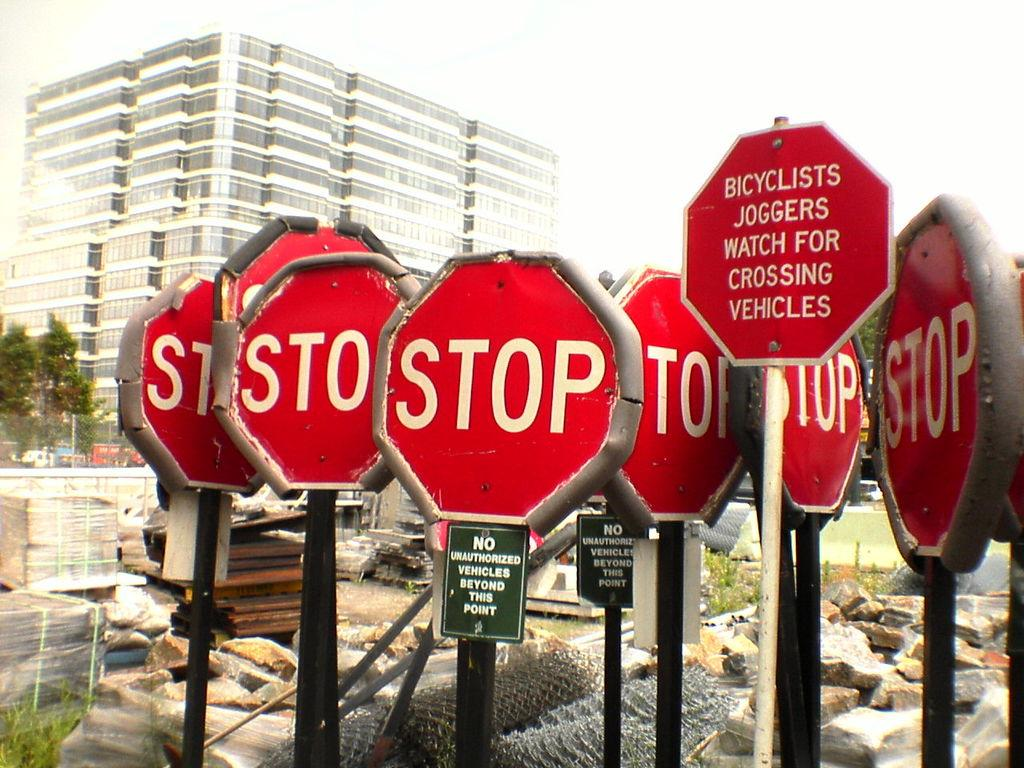Provide a one-sentence caption for the provided image. six stop signs and a red octogon warning for Bicycllst and joggers. 